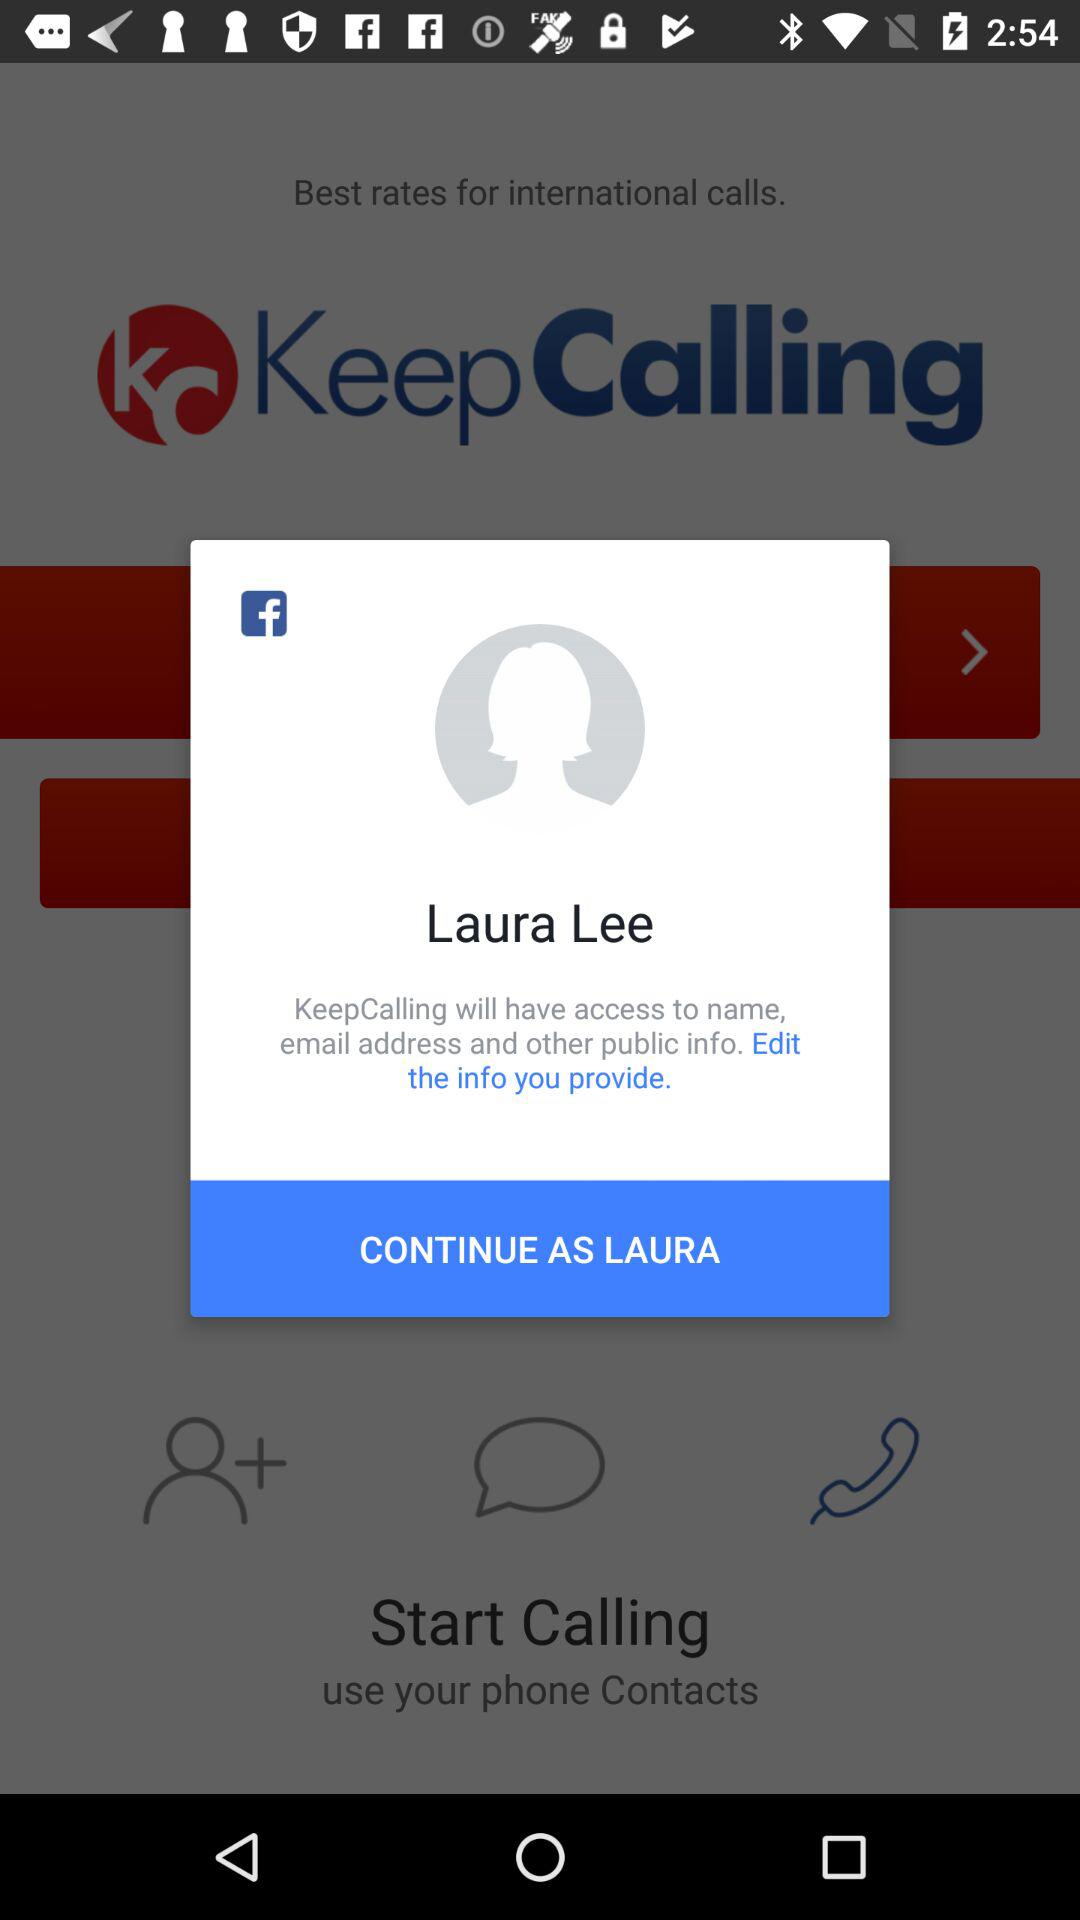What is the website to access? The website to access is "KeepCalling". 